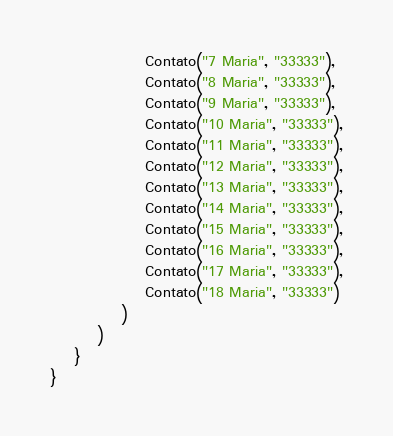<code> <loc_0><loc_0><loc_500><loc_500><_Kotlin_>                Contato("7 Maria", "33333"),
                Contato("8 Maria", "33333"),
                Contato("9 Maria", "33333"),
                Contato("10 Maria", "33333"),
                Contato("11 Maria", "33333"),
                Contato("12 Maria", "33333"),
                Contato("13 Maria", "33333"),
                Contato("14 Maria", "33333"),
                Contato("15 Maria", "33333"),
                Contato("16 Maria", "33333"),
                Contato("17 Maria", "33333"),
                Contato("18 Maria", "33333")
            )
        )
    }
}</code> 